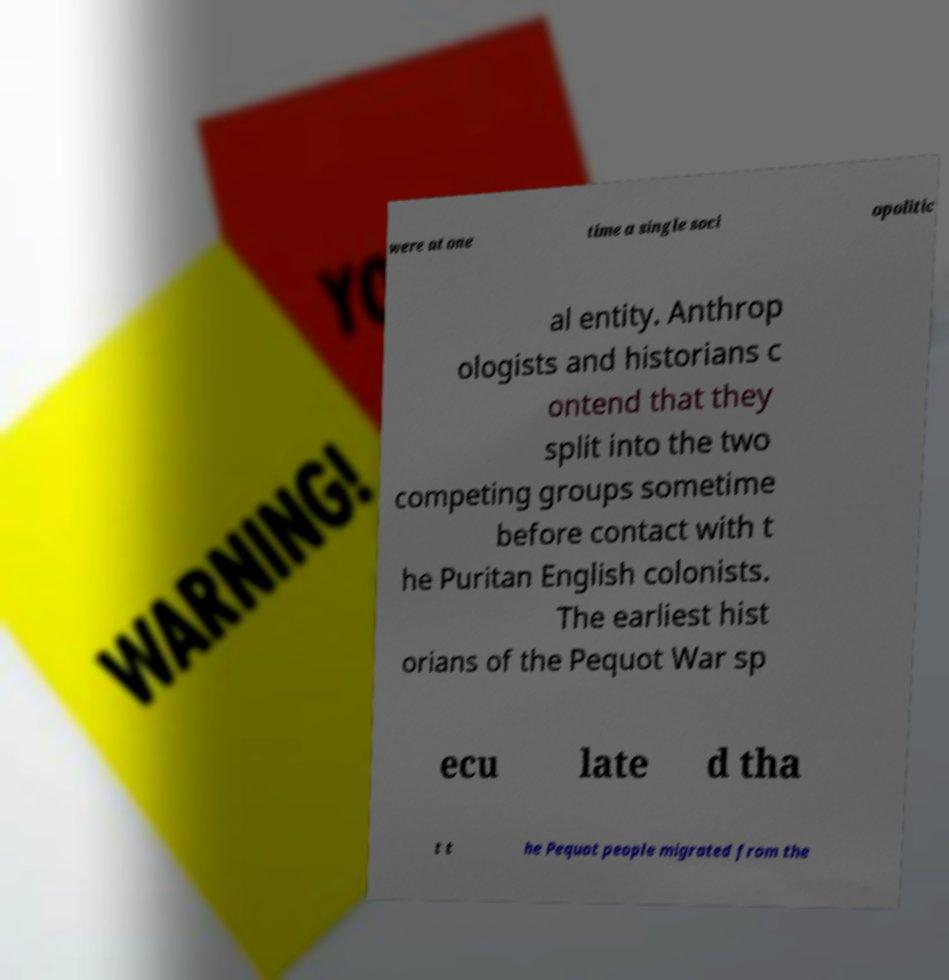For documentation purposes, I need the text within this image transcribed. Could you provide that? were at one time a single soci opolitic al entity. Anthrop ologists and historians c ontend that they split into the two competing groups sometime before contact with t he Puritan English colonists. The earliest hist orians of the Pequot War sp ecu late d tha t t he Pequot people migrated from the 